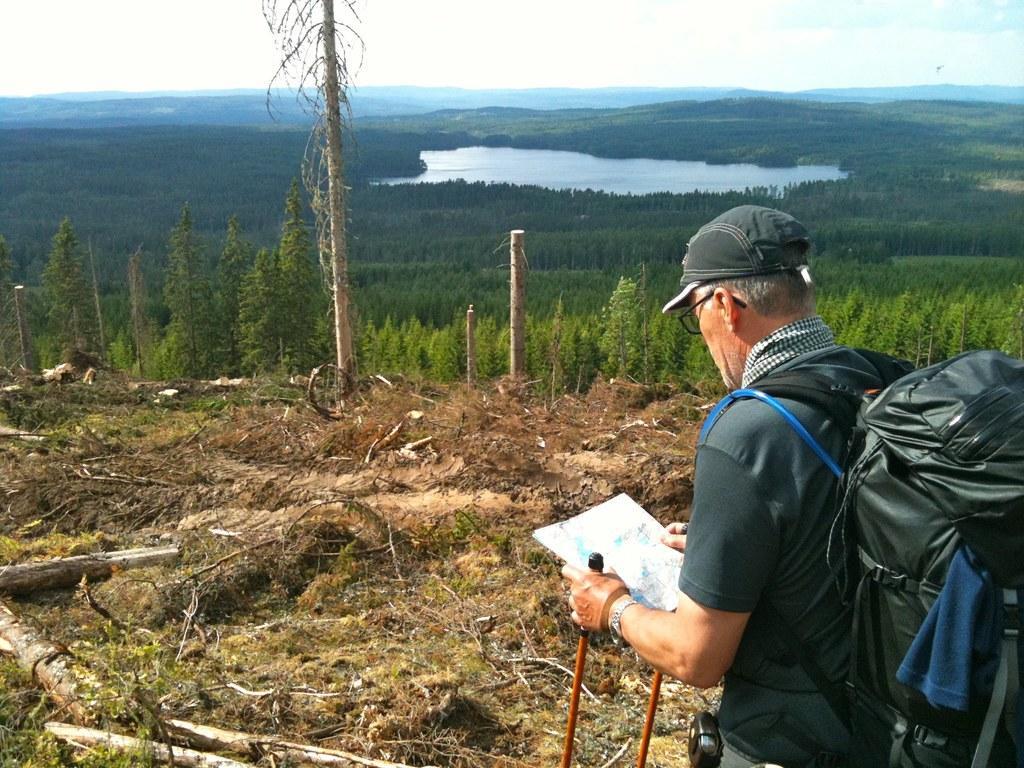Could you give a brief overview of what you see in this image? In this image I can see a person wearing a bag. He is wearing a bag he is holding a paper. In front of that person there are some trees,water and the sky. 